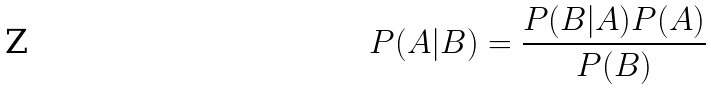Convert formula to latex. <formula><loc_0><loc_0><loc_500><loc_500>P ( A | B ) = \frac { P ( B | A ) P ( A ) } { P ( B ) }</formula> 